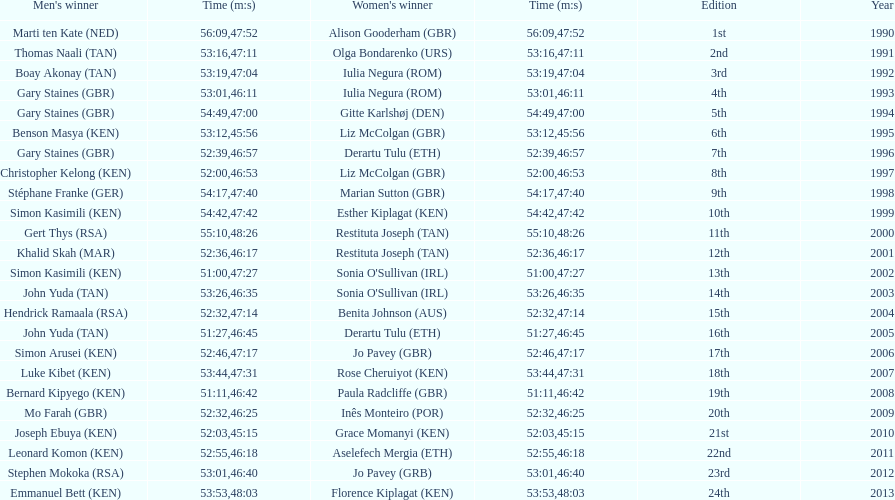Number of men's winners with a finish time under 46:58 12. 